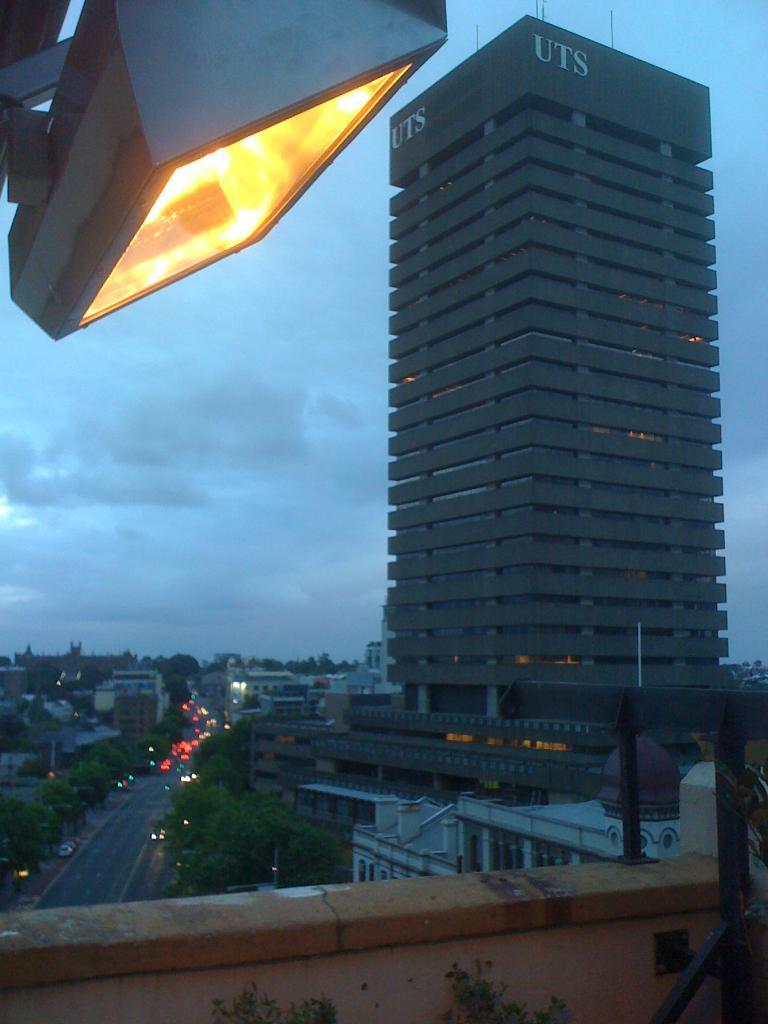What type of outdoor space is visible in the image? There is a terrace in the image. What structures can be seen in the image? There are buildings and houses in the image. What type of vegetation is present in the image? There are trees in the image. What mode of transportation can be seen in the image? There are fleets of vehicles on the road in the image. What is visible in the background of the image? The sky is visible in the background of the image. Can you describe the time of day based on the image? The image may have been taken in the evening, as indicated by the lighting. What type of flower is growing on the window in the image? There is no window or flower present in the image. 